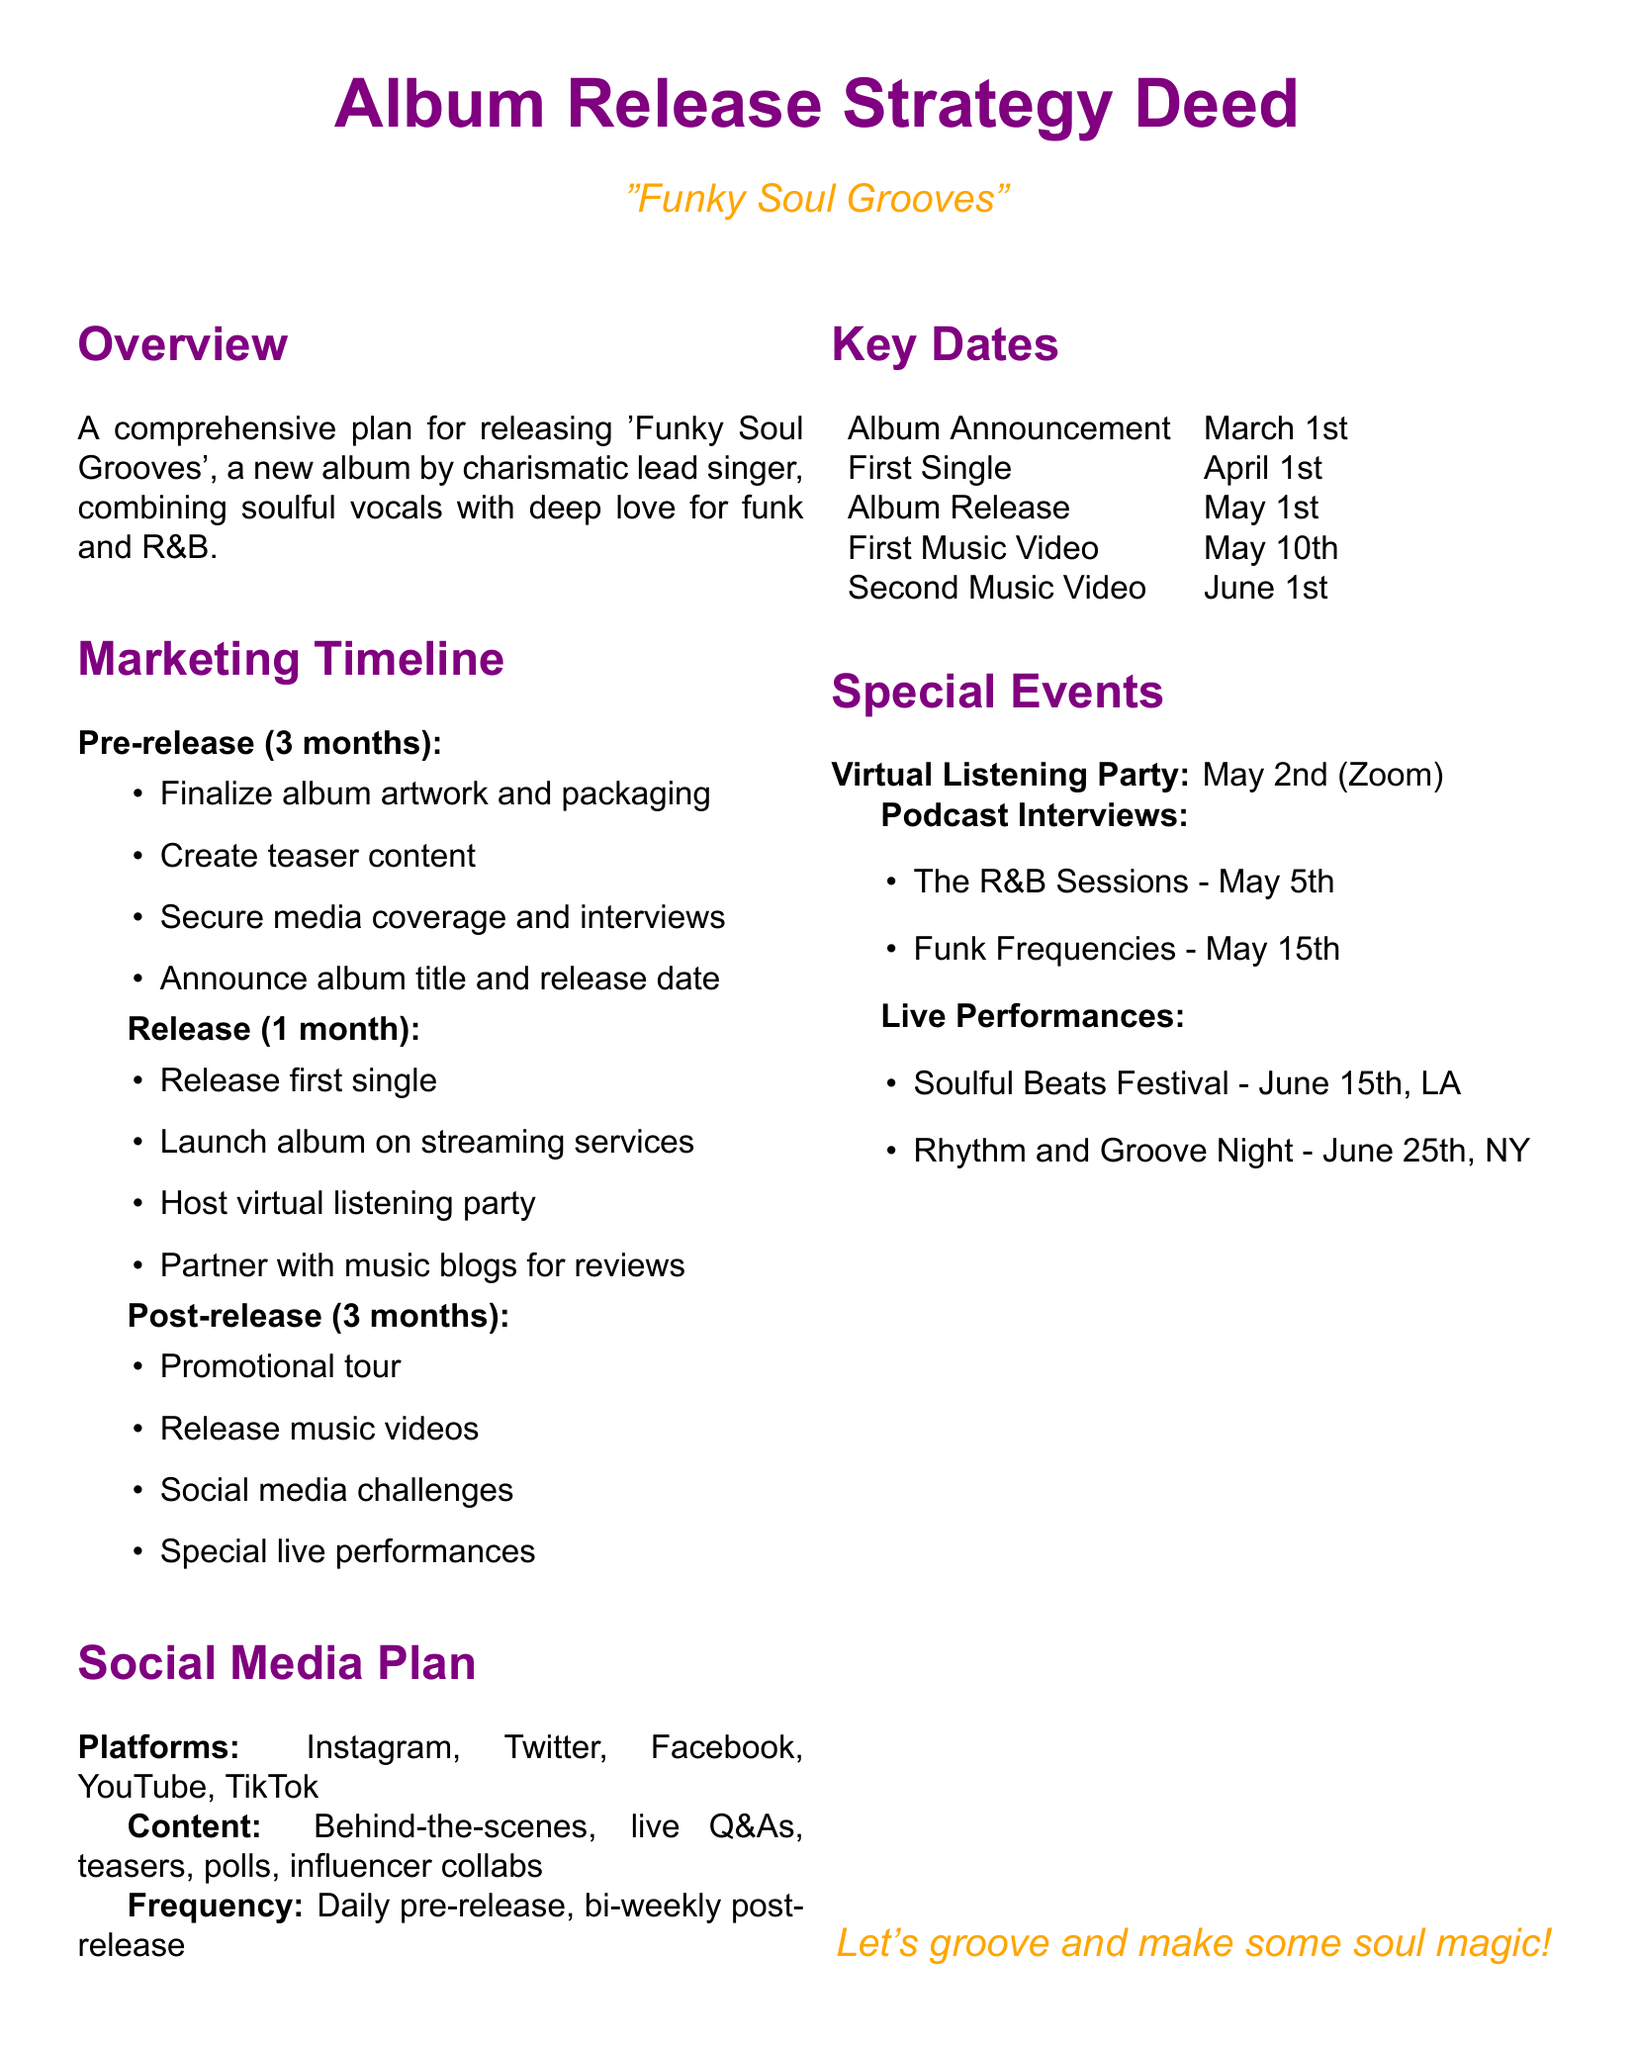What is the album title? The album title is mentioned in the document as "Funky Soul Grooves."
Answer: Funky Soul Grooves When is the album release date? The release date is listed in the key dates section of the document.
Answer: May 1st What is the first single release date? The first single release date is specified within the key dates section.
Answer: April 1st What is the date of the virtual listening party? The date for the virtual listening party is included in the special events section.
Answer: May 2nd How many music videos are scheduled for release? The count of the music videos can be found in the post-release timeline and is represented in the key dates.
Answer: Two Which platform is listed as part of the social media plan? The social media plan includes several platforms, one of which can be found in the document.
Answer: Instagram What kind of content will be shared daily in the pre-release phase? The document specifies various content types planned for social media.
Answer: Teasers Where is the Soulful Beats Festival being held? The document specifically mentions the location for the live performance at Soulful Beats Festival.
Answer: LA What type of event is planned on June 25th? The nature of the event for June 25th is specified in the document's special events section.
Answer: Live performance 